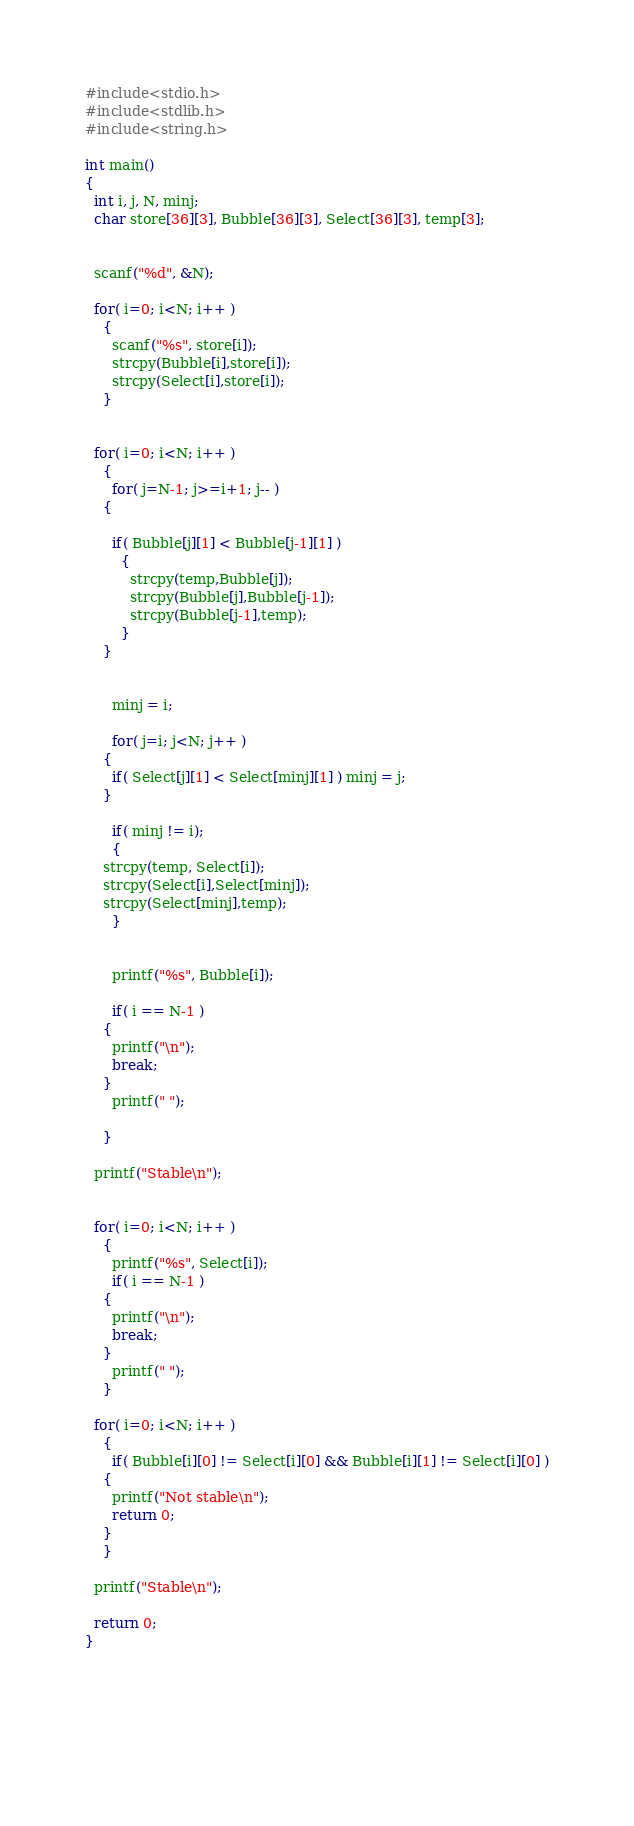<code> <loc_0><loc_0><loc_500><loc_500><_C_>#include<stdio.h>
#include<stdlib.h>
#include<string.h>

int main()
{
  int i, j, N, minj;
  char store[36][3], Bubble[36][3], Select[36][3], temp[3];

  
  scanf("%d", &N);

  for( i=0; i<N; i++ )
    {
      scanf("%s", store[i]);
      strcpy(Bubble[i],store[i]);
      strcpy(Select[i],store[i]);
    }

  
  for( i=0; i<N; i++ )
    {
      for( j=N-1; j>=i+1; j-- )
	{
	  
	  if( Bubble[j][1] < Bubble[j-1][1] )
	    {
	      strcpy(temp,Bubble[j]);
	      strcpy(Bubble[j],Bubble[j-1]);
	      strcpy(Bubble[j-1],temp);
	    }
	}
      

      minj = i;
      
      for( j=i; j<N; j++ )
	{
	  if( Select[j][1] < Select[minj][1] ) minj = j;    
	}

      if( minj != i);
      {
	strcpy(temp, Select[i]);
	strcpy(Select[i],Select[minj]);
	strcpy(Select[minj],temp);
      }


      printf("%s", Bubble[i]);
      
      if( i == N-1 )
	{
	  printf("\n");
	  break;
	}
      printf(" ");
      
    }
  
  printf("Stable\n");
  

  for( i=0; i<N; i++ )
    {
      printf("%s", Select[i]);
      if( i == N-1 )
	{
	  printf("\n");
	  break;
	}
      printf(" ");
    }

  for( i=0; i<N; i++ )
    {
      if( Bubble[i][0] != Select[i][0] && Bubble[i][1] != Select[i][0] )
	{
	  printf("Not stable\n");
	  return 0;
	}
    }
  
  printf("Stable\n");
  
  return 0;
}

  

	  
	      

</code> 